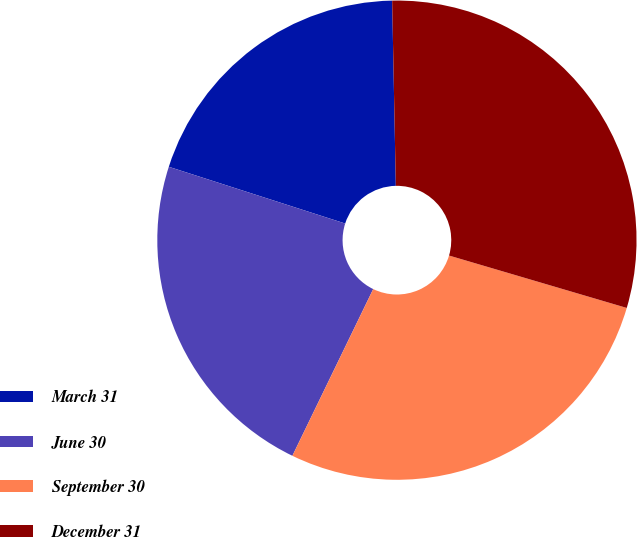<chart> <loc_0><loc_0><loc_500><loc_500><pie_chart><fcel>March 31<fcel>June 30<fcel>September 30<fcel>December 31<nl><fcel>19.73%<fcel>22.77%<fcel>27.62%<fcel>29.88%<nl></chart> 